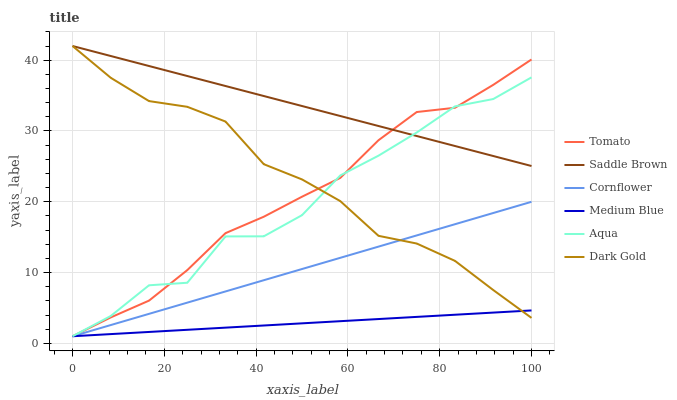Does Medium Blue have the minimum area under the curve?
Answer yes or no. Yes. Does Saddle Brown have the maximum area under the curve?
Answer yes or no. Yes. Does Cornflower have the minimum area under the curve?
Answer yes or no. No. Does Cornflower have the maximum area under the curve?
Answer yes or no. No. Is Medium Blue the smoothest?
Answer yes or no. Yes. Is Aqua the roughest?
Answer yes or no. Yes. Is Cornflower the smoothest?
Answer yes or no. No. Is Cornflower the roughest?
Answer yes or no. No. Does Tomato have the lowest value?
Answer yes or no. Yes. Does Dark Gold have the lowest value?
Answer yes or no. No. Does Saddle Brown have the highest value?
Answer yes or no. Yes. Does Cornflower have the highest value?
Answer yes or no. No. Is Cornflower less than Saddle Brown?
Answer yes or no. Yes. Is Saddle Brown greater than Cornflower?
Answer yes or no. Yes. Does Medium Blue intersect Cornflower?
Answer yes or no. Yes. Is Medium Blue less than Cornflower?
Answer yes or no. No. Is Medium Blue greater than Cornflower?
Answer yes or no. No. Does Cornflower intersect Saddle Brown?
Answer yes or no. No. 